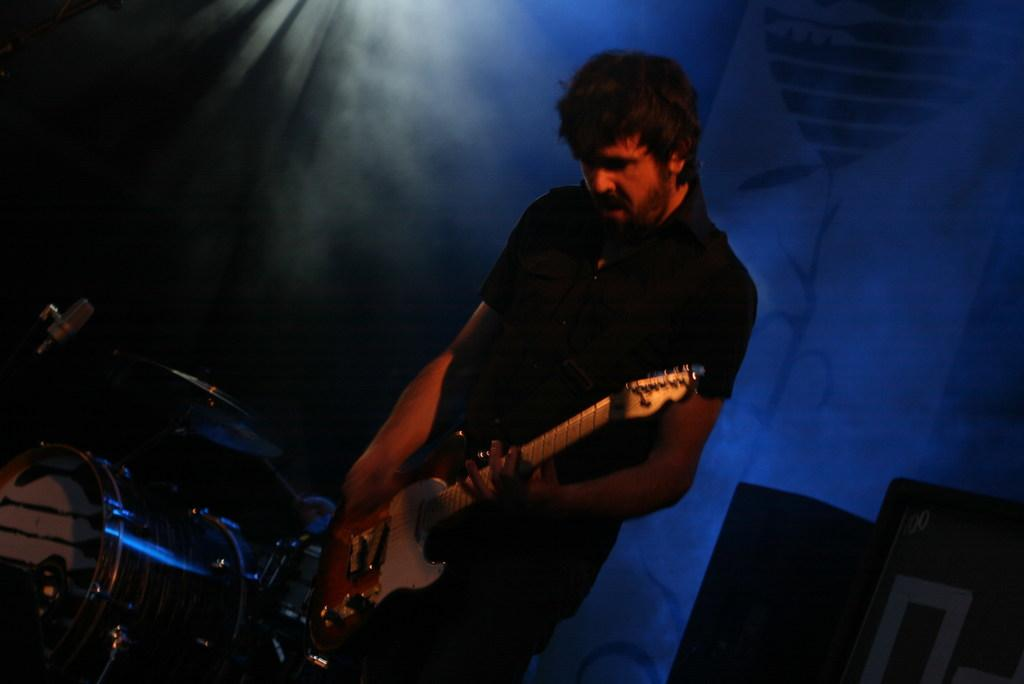What is the man in the image doing? The man is playing a guitar and singing. What instrument can be seen in the background of the image? There are drums in the background of the image. What can be seen illuminating the background of the image? There is a light in the background of the image. What is present in the background of the image that might be used for amplifying sound? There is a speaker in the background of the image. What type of decoration is present in the background of the image? There is a poster in the background of the image. What type of corn is being used as a microphone in the image? There is no corn present in the image, and therefore no corn is being used as a microphone. 